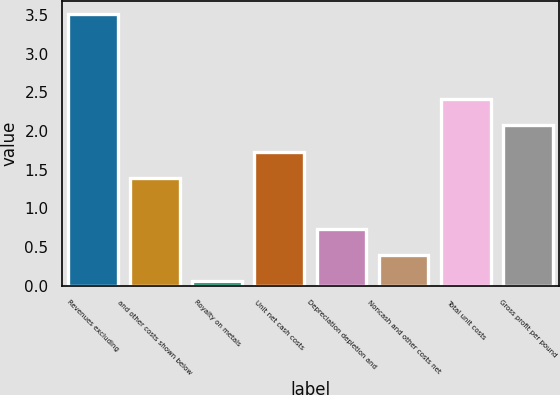Convert chart to OTSL. <chart><loc_0><loc_0><loc_500><loc_500><bar_chart><fcel>Revenues excluding<fcel>and other costs shown below<fcel>Royalty on metals<fcel>Unit net cash costs<fcel>Depreciation depletion and<fcel>Noncash and other costs net<fcel>Total unit costs<fcel>Gross profit per pound<nl><fcel>3.51<fcel>1.39<fcel>0.06<fcel>1.73<fcel>0.74<fcel>0.4<fcel>2.42<fcel>2.08<nl></chart> 